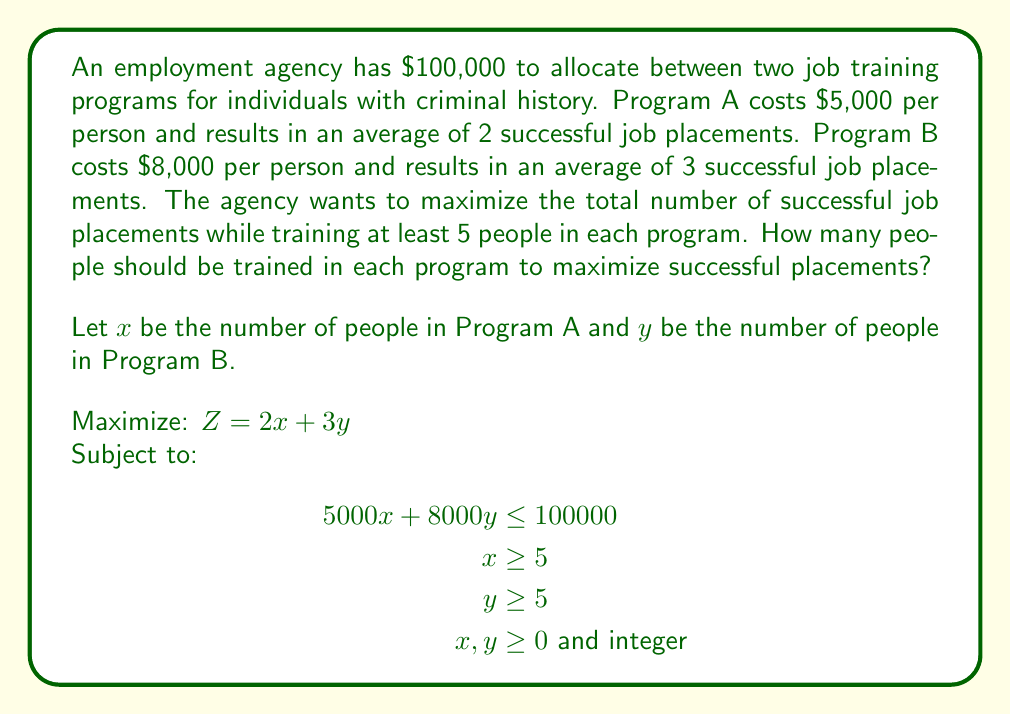Solve this math problem. To solve this linear programming problem:

1) First, we graph the constraints:
   $5000x + 8000y = 100000$ is our budget line
   $x = 5$ and $y = 5$ are our minimum requirements

2) The feasible region is the area that satisfies all constraints.

3) The optimal solution will be at one of the corner points of this region.

4) The corner points are:
   (5, 5), (5, 11.875), (15, 5), and (10, 8.75)

5) We can't use (5, 11.875) or (10, 8.75) as y must be an integer.

6) Evaluate Z at the remaining integer points:
   At (5, 5): Z = 2(5) + 3(5) = 25
   At (15, 5): Z = 2(15) + 3(5) = 45

7) We also need to check the nearest integer points to (10, 8.75):
   At (10, 8): Z = 2(10) + 3(8) = 44
   At (11, 8): Z = 2(11) + 3(8) = 46

8) The maximum value of Z is 46, occurring at (11, 8).

Therefore, the optimal solution is to train 11 people in Program A and 8 people in Program B.
Answer: 11 in Program A, 8 in Program B 